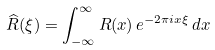<formula> <loc_0><loc_0><loc_500><loc_500>\widehat { R } ( \xi ) = \int _ { - \infty } ^ { \infty } R ( x ) \, e ^ { - 2 \pi i x \xi } \, d x</formula> 